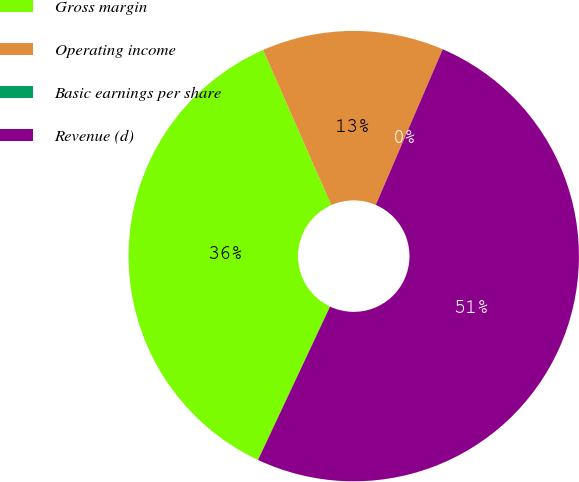Convert chart to OTSL. <chart><loc_0><loc_0><loc_500><loc_500><pie_chart><fcel>Gross margin<fcel>Operating income<fcel>Basic earnings per share<fcel>Revenue (d)<nl><fcel>36.42%<fcel>13.06%<fcel>0.0%<fcel>50.52%<nl></chart> 